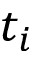Convert formula to latex. <formula><loc_0><loc_0><loc_500><loc_500>t _ { i }</formula> 